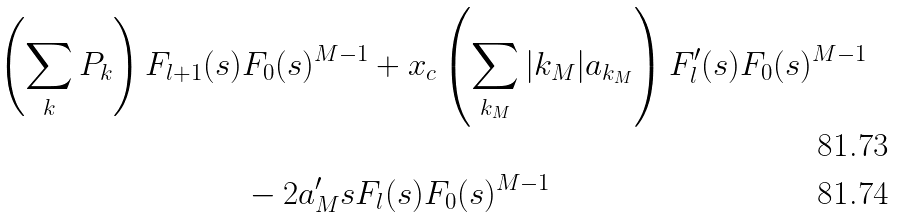<formula> <loc_0><loc_0><loc_500><loc_500>\left ( \sum _ { k } P _ { k } \right ) F _ { l + 1 } ( s ) & F _ { 0 } ( s ) ^ { M - 1 } + x _ { c } \left ( \sum _ { { k } _ { M } } | { k } _ { M } | a _ { { k } _ { M } } \right ) F _ { l } ^ { \prime } ( s ) F _ { 0 } ( s ) ^ { M - 1 } \\ & - 2 a _ { M } ^ { \prime } s F _ { l } ( s ) F _ { 0 } ( s ) ^ { M - 1 }</formula> 